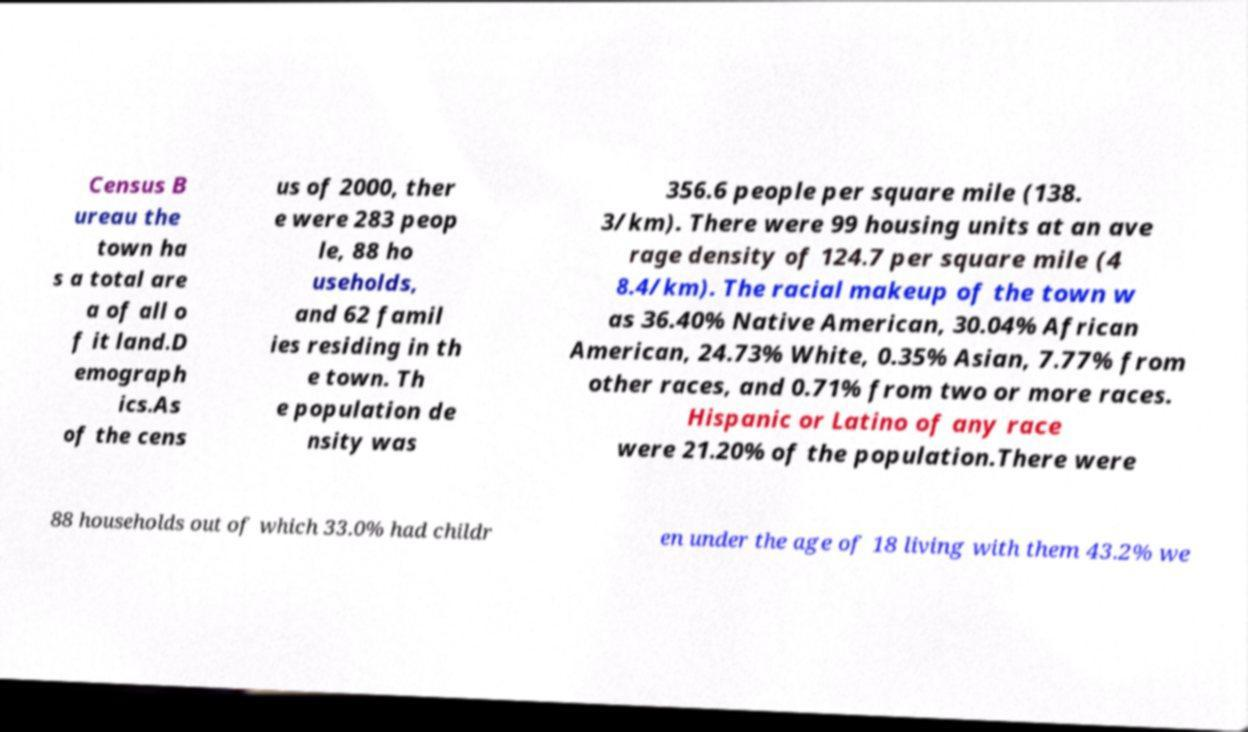What messages or text are displayed in this image? I need them in a readable, typed format. Census B ureau the town ha s a total are a of all o f it land.D emograph ics.As of the cens us of 2000, ther e were 283 peop le, 88 ho useholds, and 62 famil ies residing in th e town. Th e population de nsity was 356.6 people per square mile (138. 3/km). There were 99 housing units at an ave rage density of 124.7 per square mile (4 8.4/km). The racial makeup of the town w as 36.40% Native American, 30.04% African American, 24.73% White, 0.35% Asian, 7.77% from other races, and 0.71% from two or more races. Hispanic or Latino of any race were 21.20% of the population.There were 88 households out of which 33.0% had childr en under the age of 18 living with them 43.2% we 